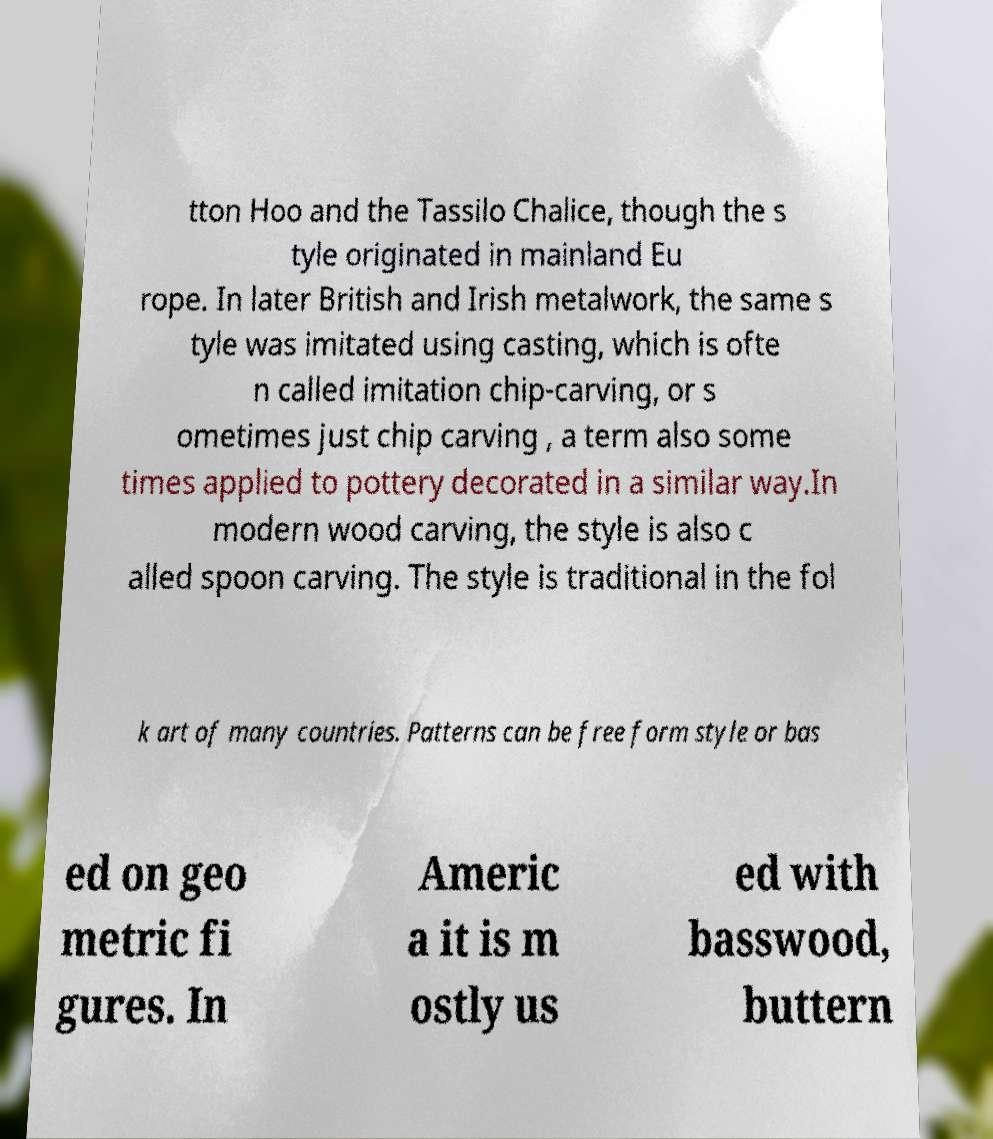I need the written content from this picture converted into text. Can you do that? tton Hoo and the Tassilo Chalice, though the s tyle originated in mainland Eu rope. In later British and Irish metalwork, the same s tyle was imitated using casting, which is ofte n called imitation chip-carving, or s ometimes just chip carving , a term also some times applied to pottery decorated in a similar way.In modern wood carving, the style is also c alled spoon carving. The style is traditional in the fol k art of many countries. Patterns can be free form style or bas ed on geo metric fi gures. In Americ a it is m ostly us ed with basswood, buttern 